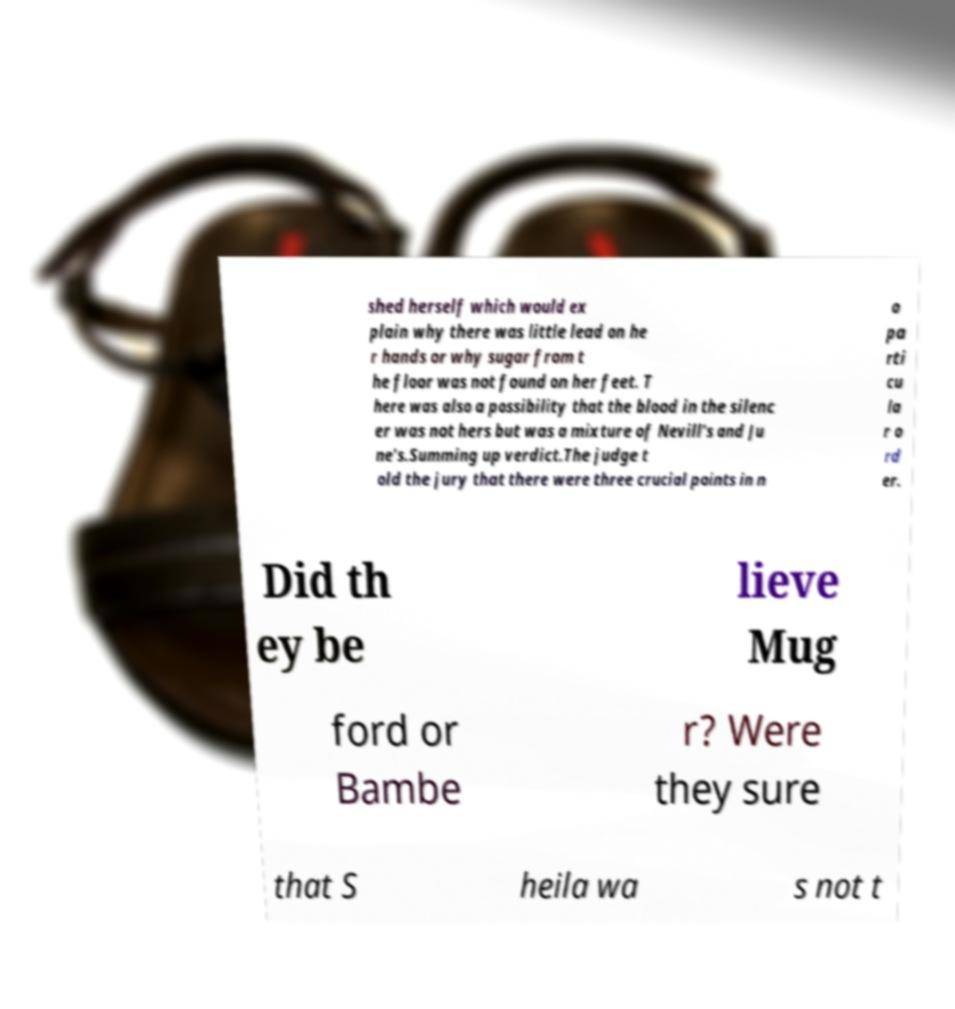Can you accurately transcribe the text from the provided image for me? shed herself which would ex plain why there was little lead on he r hands or why sugar from t he floor was not found on her feet. T here was also a possibility that the blood in the silenc er was not hers but was a mixture of Nevill's and Ju ne's.Summing up verdict.The judge t old the jury that there were three crucial points in n o pa rti cu la r o rd er. Did th ey be lieve Mug ford or Bambe r? Were they sure that S heila wa s not t 